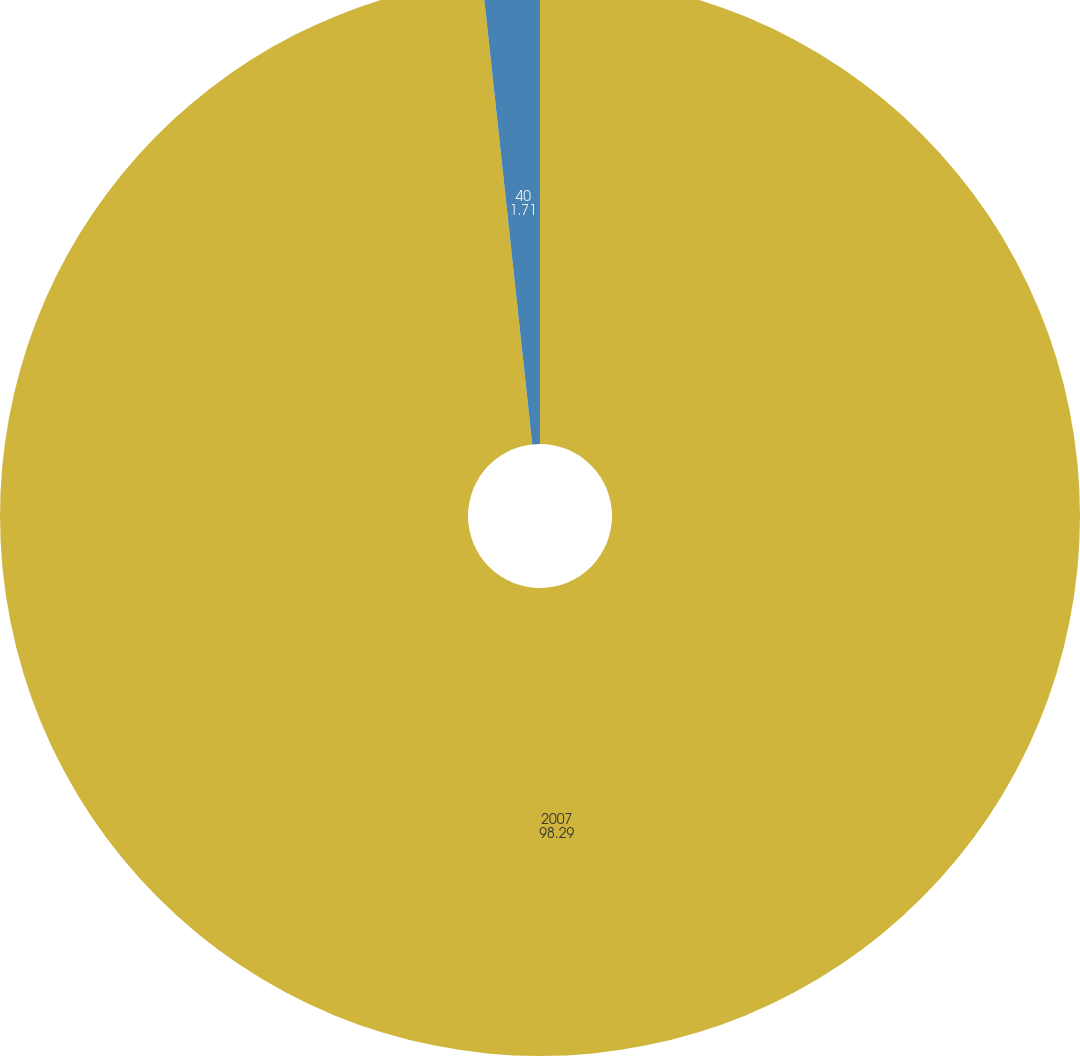Convert chart to OTSL. <chart><loc_0><loc_0><loc_500><loc_500><pie_chart><fcel>2007<fcel>40<nl><fcel>98.29%<fcel>1.71%<nl></chart> 